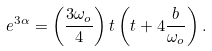Convert formula to latex. <formula><loc_0><loc_0><loc_500><loc_500>e ^ { 3 \alpha } = \left ( \frac { 3 \omega _ { o } } { 4 } \right ) t \left ( t + 4 \frac { b } { \omega _ { o } } \right ) .</formula> 